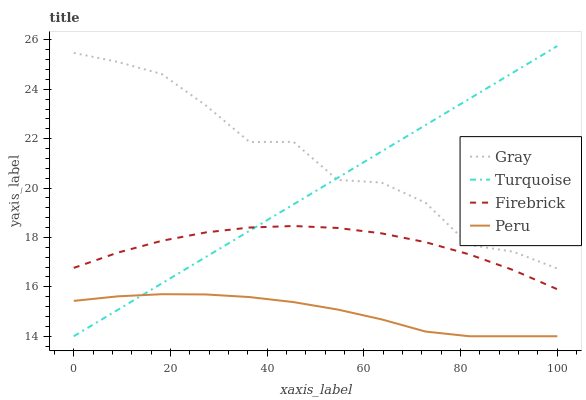Does Peru have the minimum area under the curve?
Answer yes or no. Yes. Does Gray have the maximum area under the curve?
Answer yes or no. Yes. Does Turquoise have the minimum area under the curve?
Answer yes or no. No. Does Turquoise have the maximum area under the curve?
Answer yes or no. No. Is Turquoise the smoothest?
Answer yes or no. Yes. Is Gray the roughest?
Answer yes or no. Yes. Is Firebrick the smoothest?
Answer yes or no. No. Is Firebrick the roughest?
Answer yes or no. No. Does Firebrick have the lowest value?
Answer yes or no. No. Does Turquoise have the highest value?
Answer yes or no. Yes. Does Firebrick have the highest value?
Answer yes or no. No. Is Peru less than Gray?
Answer yes or no. Yes. Is Gray greater than Peru?
Answer yes or no. Yes. Does Peru intersect Turquoise?
Answer yes or no. Yes. Is Peru less than Turquoise?
Answer yes or no. No. Is Peru greater than Turquoise?
Answer yes or no. No. Does Peru intersect Gray?
Answer yes or no. No. 